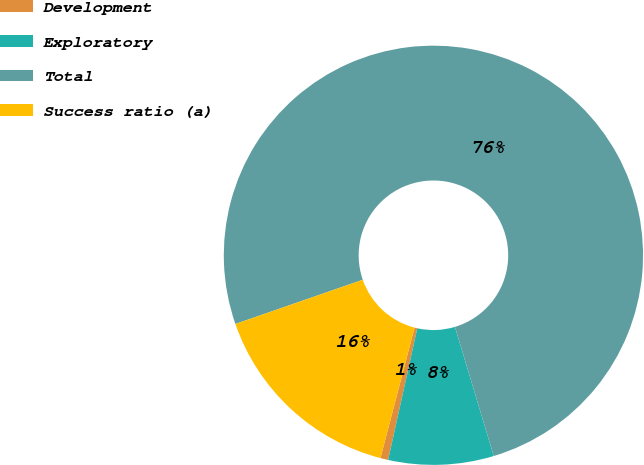<chart> <loc_0><loc_0><loc_500><loc_500><pie_chart><fcel>Development<fcel>Exploratory<fcel>Total<fcel>Success ratio (a)<nl><fcel>0.6%<fcel>8.11%<fcel>75.67%<fcel>15.62%<nl></chart> 